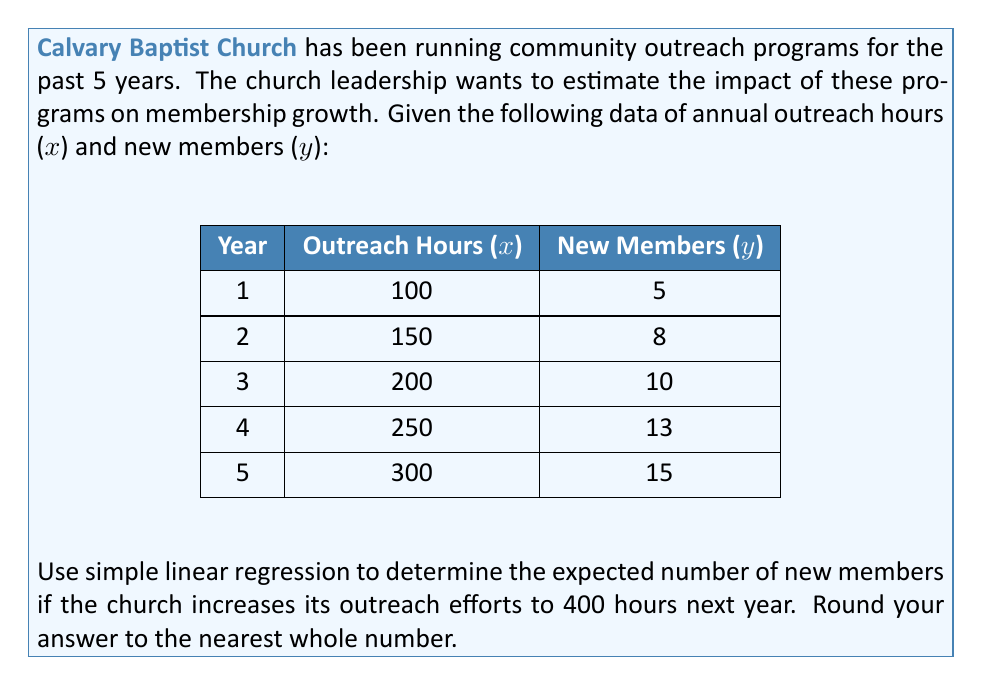Teach me how to tackle this problem. To solve this problem, we'll use simple linear regression to model the relationship between outreach hours and new members. Then, we'll use the resulting equation to predict the number of new members for 400 outreach hours.

Step 1: Calculate the means of x and y
$$\bar{x} = \frac{100 + 150 + 200 + 250 + 300}{5} = 200$$
$$\bar{y} = \frac{5 + 8 + 10 + 13 + 15}{5} = 10.2$$

Step 2: Calculate the slope (b) of the regression line
$$b = \frac{\sum(x_i - \bar{x})(y_i - \bar{y})}{\sum(x_i - \bar{x})^2}$$

$$b = \frac{(-100)(-5.2) + (-50)(-2.2) + (0)(-0.2) + (50)(2.8) + (100)(4.8)}{(-100)^2 + (-50)^2 + (0)^2 + (50)^2 + (100)^2}$$

$$b = \frac{520 + 110 + 0 + 140 + 480}{40000} = \frac{1250}{40000} = 0.03125$$

Step 3: Calculate the y-intercept (a) of the regression line
$$a = \bar{y} - b\bar{x} = 10.2 - 0.03125(200) = 4.05$$

Step 4: Write the regression equation
$$y = 0.03125x + 4.05$$

Step 5: Predict the number of new members for 400 outreach hours
$$y = 0.03125(400) + 4.05 = 16.55$$

Step 6: Round to the nearest whole number
16.55 rounds to 17
Answer: 17 new members 